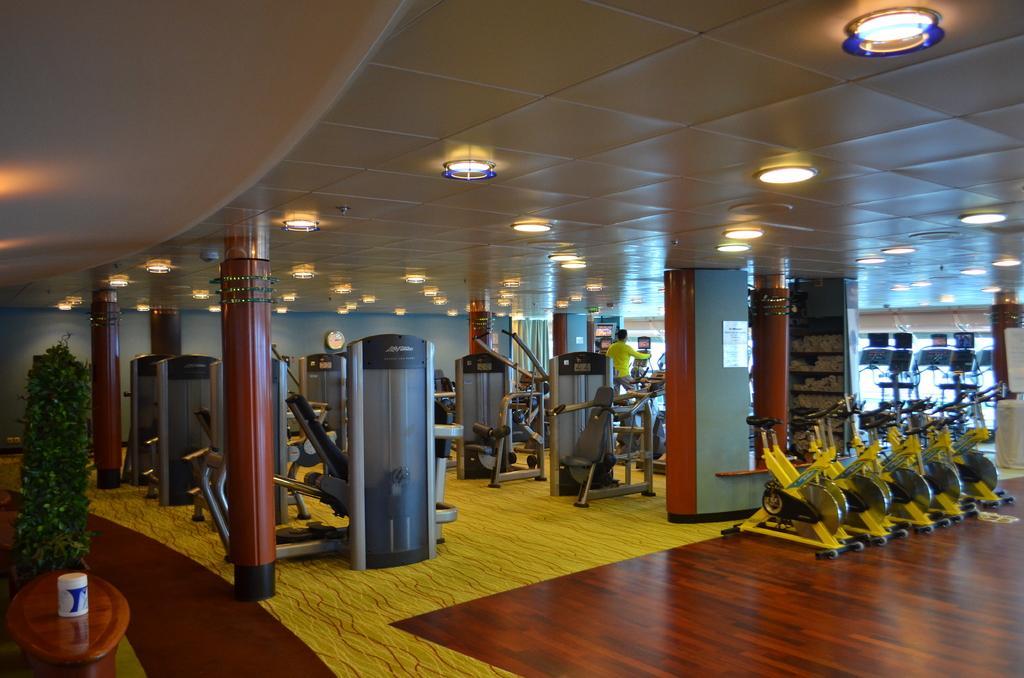Could you give a brief overview of what you see in this image? In this picture we can see on the floor there are some gym equipments, pillars, house plant and a table and on the table there is a white cup. Behind the gym equipments there is a wall and there are ceiling lights on the top. 